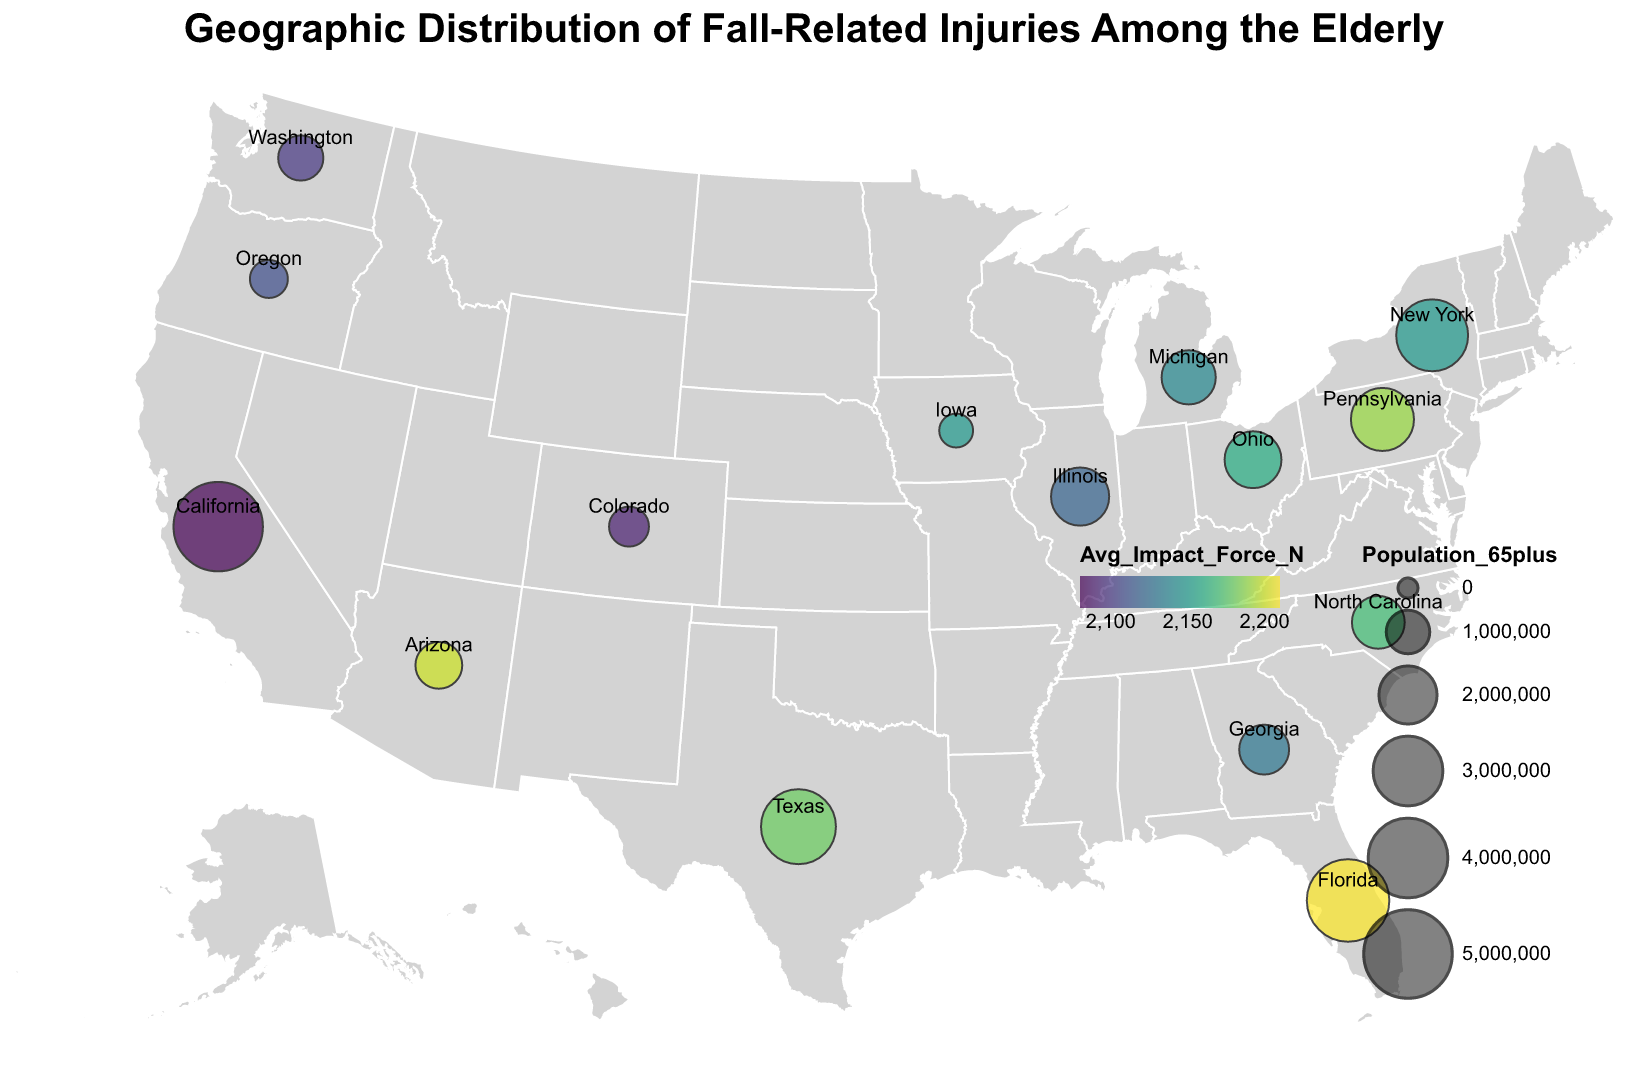What is the title of the figure? The title is displayed at the top of the figure and usually indicates the main topic of the data presented.
Answer: Geographic Distribution of Fall-Related Injuries Among the Elderly Which region has the highest urban incidence of fall-related injuries? Look for the region with the highest value in the 'Urban_Incidence' field from the data points plotted on the map. This is represented by the 'Urban_Incidence' tooltip.
Answer: Florida What is the rural incidence of fall-related injuries in Texas? By examining the tooltip for Texas, you will find the 'Rural_Incidence' value.
Answer: 33.5 Is the average impact force higher in urban or rural areas of New York? Compare the 'Avg_Impact_Force_N' for urban and rural New York by clicking or hovering over the data point for New York. Both urban and rural areas have the same 'Avg_Impact_Force_N'.
Answer: Same Which state has the smallest elderly population but shows a relatively high urban incidence rate? Look for the smallest 'Population_65plus' value and then check the 'Urban_Incidence' for a high rate.
Answer: Iowa How does the rural incidence in Ohio compare to that in Georgia? Compare the 'Rural_Incidence' values for Ohio and Georgia. Look for the tooltip showing both values when you hover over the respective points on the map.
Answer: Higher in Ohio Which region shows a larger difference in fall-related injury incidence between urban and rural areas, Pennsylvania or Arizona? Calculate the difference between 'Urban_Incidence' and 'Rural_Incidence' for Pennsylvania and Arizona and compare these differences. Pennsylvania: 33.9 - 30.6 = 3.3; Arizona: 34.2 - 29.4 = 4.8, thus Arizona has a larger difference.
Answer: Arizona What is the most common range of average impact forces in the displayed regions, according to the color scale? The 'Avg_Impact_Force_N' is encoded as color on the map. Identify the color range that appears most frequently on the map.
Answer: Around 2150 N For states with over 2 million elderly residents, what is the average rural incidence of fall-related injuries? Filter the states having 'Population_65plus' over 2 million and calculate the average 'Rural_Incidence' for these states. New York: 28.7, California: 26.9, Florida: 31.2, Texas: 33.5, Pennsylvania: 30.6. Average: (28.7 + 26.9 + 31.2 + 33.5 + 30.6) / 5 = 30.2
Answer: 30.2 How does the average impact force relate to the population size among the different states? Observe the correlation between the sizes of the data points (indicating 'Population_65plus') and the color encoding the 'Avg_Impact_Force_N'.
Answer: No clear pattern Which region has the lowest average impact force? Look for the data point with the lowest 'Avg_Impact_Force_N' value in the tooltips.
Answer: California 